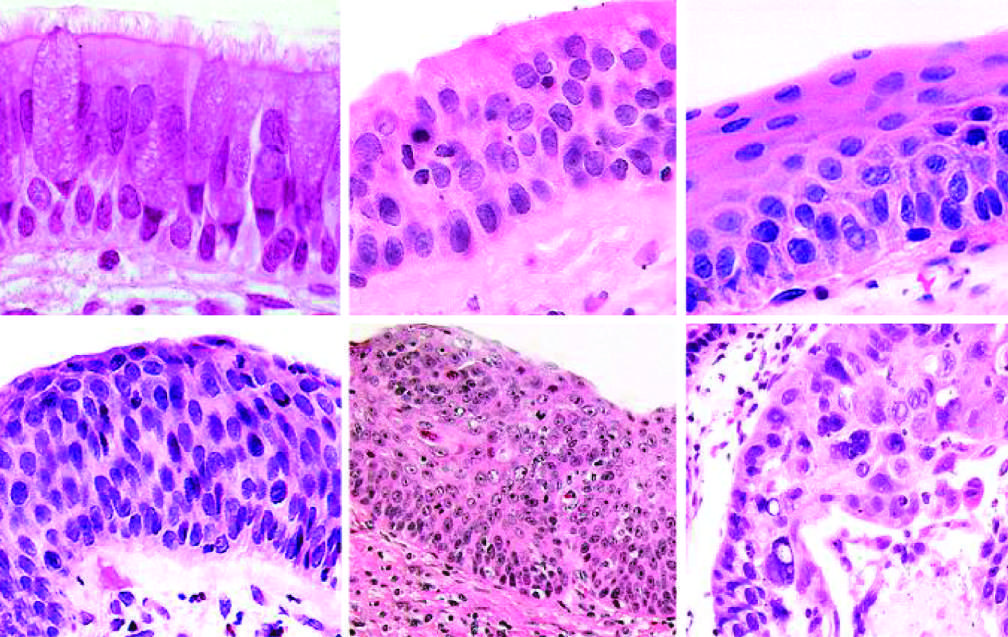do more ominous changes include the appearance of squamous dysplasia, characterized by the presence of disordered squamous epithelium, with loss of nuclear polarity, nuclear hyperchromasia, pleomorphism, and mitotic figures?
Answer the question using a single word or phrase. Yes 